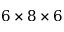<formula> <loc_0><loc_0><loc_500><loc_500>6 \times 8 \times 6</formula> 